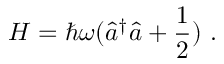Convert formula to latex. <formula><loc_0><loc_0><loc_500><loc_500>H = \hbar { \omega } ( { \hat { a } } ^ { \dagger } { \hat { a } } + { \frac { 1 } { 2 } } ) .</formula> 